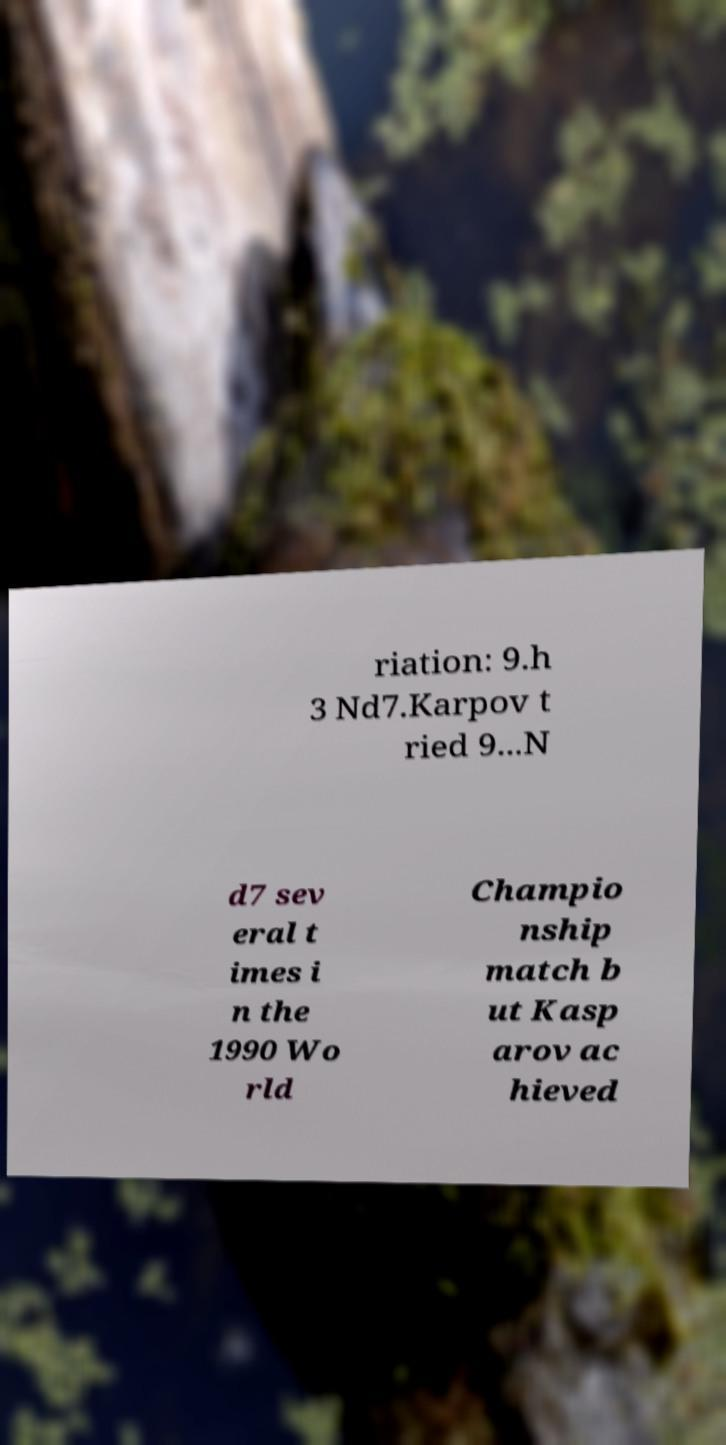Can you read and provide the text displayed in the image?This photo seems to have some interesting text. Can you extract and type it out for me? riation: 9.h 3 Nd7.Karpov t ried 9...N d7 sev eral t imes i n the 1990 Wo rld Champio nship match b ut Kasp arov ac hieved 